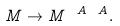<formula> <loc_0><loc_0><loc_500><loc_500>M \rightarrow M ^ { \ A \ A } .</formula> 